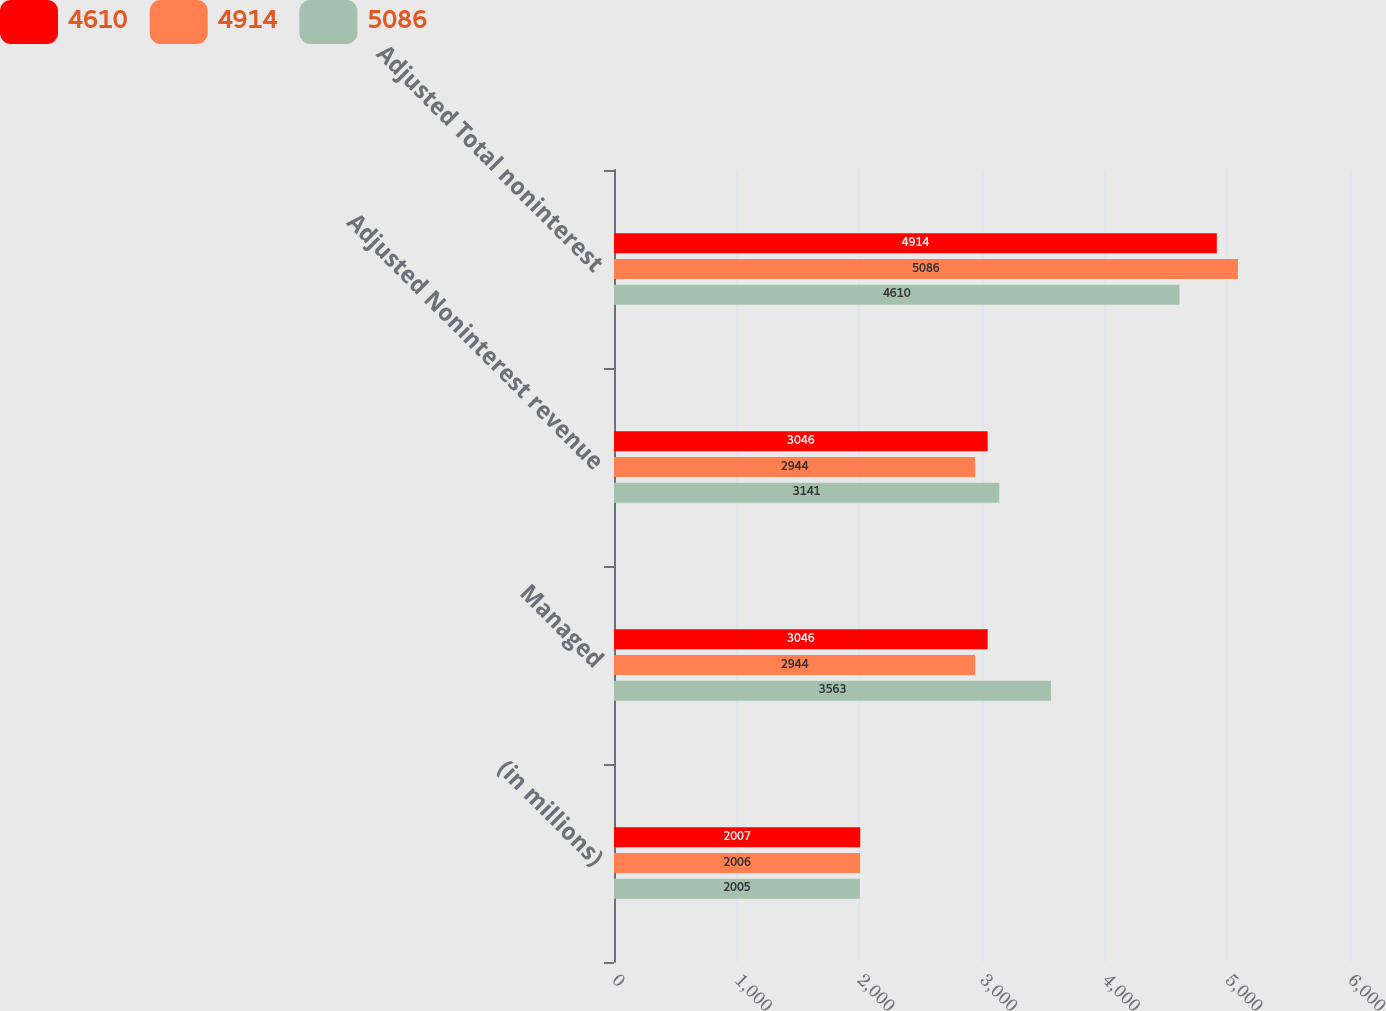Convert chart. <chart><loc_0><loc_0><loc_500><loc_500><stacked_bar_chart><ecel><fcel>(in millions)<fcel>Managed<fcel>Adjusted Noninterest revenue<fcel>Adjusted Total noninterest<nl><fcel>4610<fcel>2007<fcel>3046<fcel>3046<fcel>4914<nl><fcel>4914<fcel>2006<fcel>2944<fcel>2944<fcel>5086<nl><fcel>5086<fcel>2005<fcel>3563<fcel>3141<fcel>4610<nl></chart> 